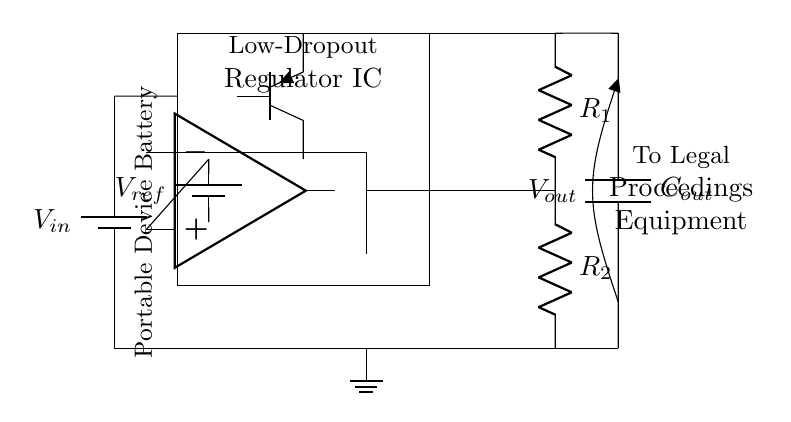What is the input voltage for the circuit? The input voltage is represented by the symbol \(V_{in}\) on the battery connected at the top left of the circuit.
Answer: \(V_{in}\) What type of regulator is depicted in the circuit? The circuit features a Low-Dropout Regulator (LDO), which is indicated by the label on the rectangle marked "Low-Dropout Regulator IC."
Answer: Low-Dropout Regulator What does the reference voltage represent? The reference voltage is denoted as \(V_{ref}\) and is connected to the positive terminal of the operational amplifier, indicating a fixed voltage used for regulation.
Answer: \(V_{ref}\) What components are included in the feedback network? The feedback network consists of two resistors labeled \(R_1\) and \(R_2\), which connect to the output voltage and the operational amplifier's negative input.
Answer: Resistors \(R_1\) and \(R_2\) How does the regulator maintain output voltage? The regulator maintains output voltage by using the error amplifier, which compares the output voltage to the reference voltage and adjusts the pass transistor to stabilize the output.
Answer: By adjusting the pass transistor What type of output capacitor is used in the circuit? The output capacitor is labeled as \(C_{out}\) and is positioned at the output node, crucial for stabilizing the output voltage and filtering noise.
Answer: Capacitor \(C_{out}\) What is the function of the operational amplifier in this circuit? The operational amplifier serves as the error amplifier, which compares the output voltage with the reference voltage to regulate the output voltage accurately.
Answer: Error amplifier 